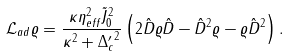Convert formula to latex. <formula><loc_0><loc_0><loc_500><loc_500>\mathcal { L } _ { a d } \varrho = \frac { \kappa \eta _ { e f f } ^ { 2 } \tilde { J } _ { 0 } ^ { 2 } } { \kappa ^ { 2 } + { \Delta _ { c } ^ { \prime } } ^ { 2 } } \left ( 2 \hat { D } \varrho \hat { D } - \hat { D } ^ { 2 } \varrho - \varrho \hat { D } ^ { 2 } \right ) .</formula> 